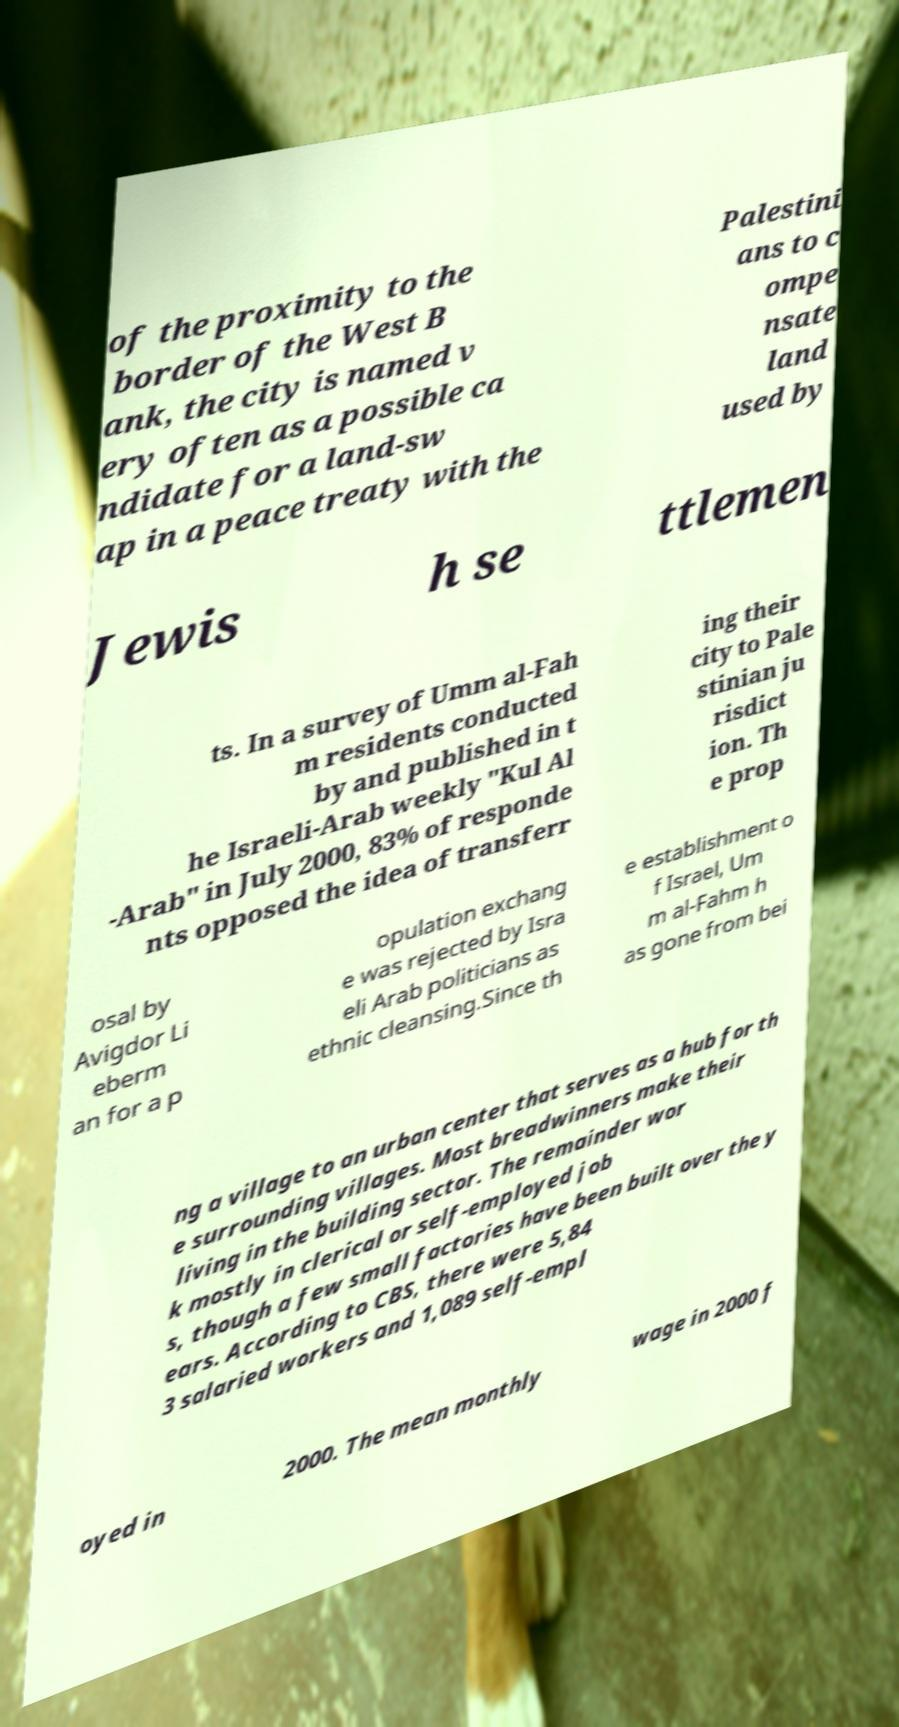There's text embedded in this image that I need extracted. Can you transcribe it verbatim? of the proximity to the border of the West B ank, the city is named v ery often as a possible ca ndidate for a land-sw ap in a peace treaty with the Palestini ans to c ompe nsate land used by Jewis h se ttlemen ts. In a survey of Umm al-Fah m residents conducted by and published in t he Israeli-Arab weekly "Kul Al -Arab" in July 2000, 83% of responde nts opposed the idea of transferr ing their city to Pale stinian ju risdict ion. Th e prop osal by Avigdor Li eberm an for a p opulation exchang e was rejected by Isra eli Arab politicians as ethnic cleansing.Since th e establishment o f Israel, Um m al-Fahm h as gone from bei ng a village to an urban center that serves as a hub for th e surrounding villages. Most breadwinners make their living in the building sector. The remainder wor k mostly in clerical or self-employed job s, though a few small factories have been built over the y ears. According to CBS, there were 5,84 3 salaried workers and 1,089 self-empl oyed in 2000. The mean monthly wage in 2000 f 